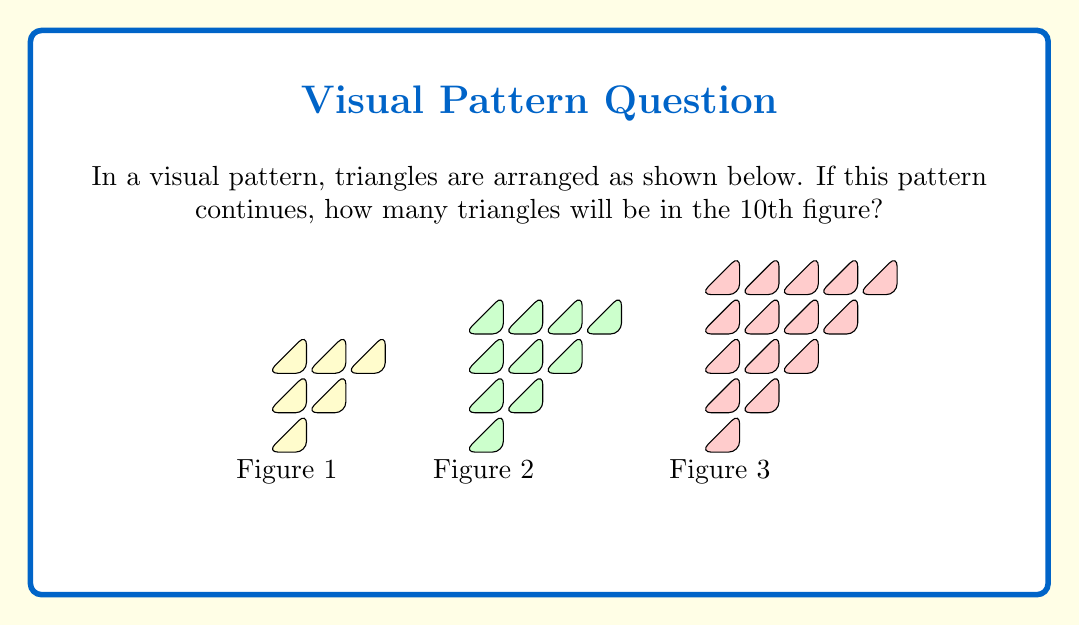What is the answer to this math problem? Let's approach this step-by-step:

1) First, let's observe the pattern:
   Figure 1 has 1 triangle
   Figure 2 has 1 + 2 + 1 = 4 triangles
   Figure 3 has 1 + 2 + 3 + 2 + 1 = 9 triangles

2) We can see that the number of triangles in each figure forms a sequence:
   1, 4, 9, ...

3) This sequence looks familiar. It's the sequence of square numbers!

4) We can confirm this by looking at the relationship between the figure number and the number of triangles:
   Figure 1: $1^2 = 1$
   Figure 2: $2^2 = 4$
   Figure 3: $3^2 = 9$

5) We can now generalize this pattern:
   For Figure $n$, the number of triangles is $n^2$

6) The question asks about the 10th figure, so we need to calculate:
   $10^2 = 100$

Therefore, the 10th figure will have 100 triangles.
Answer: 100 